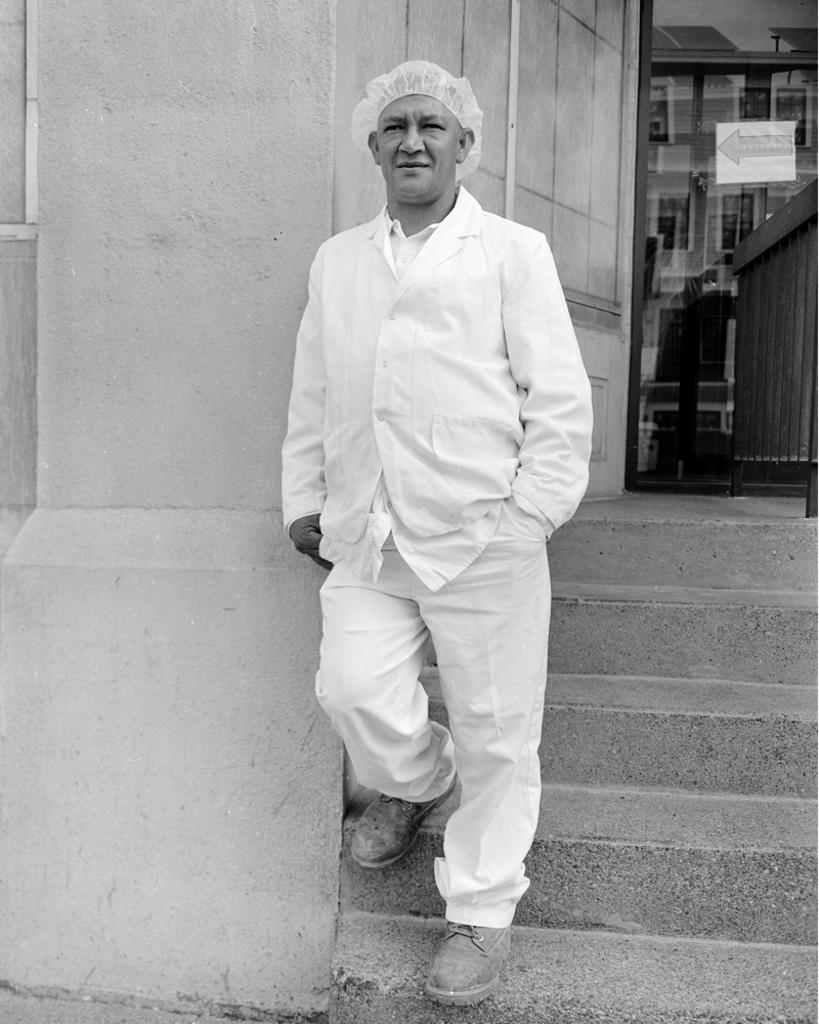Could you give a brief overview of what you see in this image? In the middle of the image a man is walking and smiling. Behind him there is wall. 